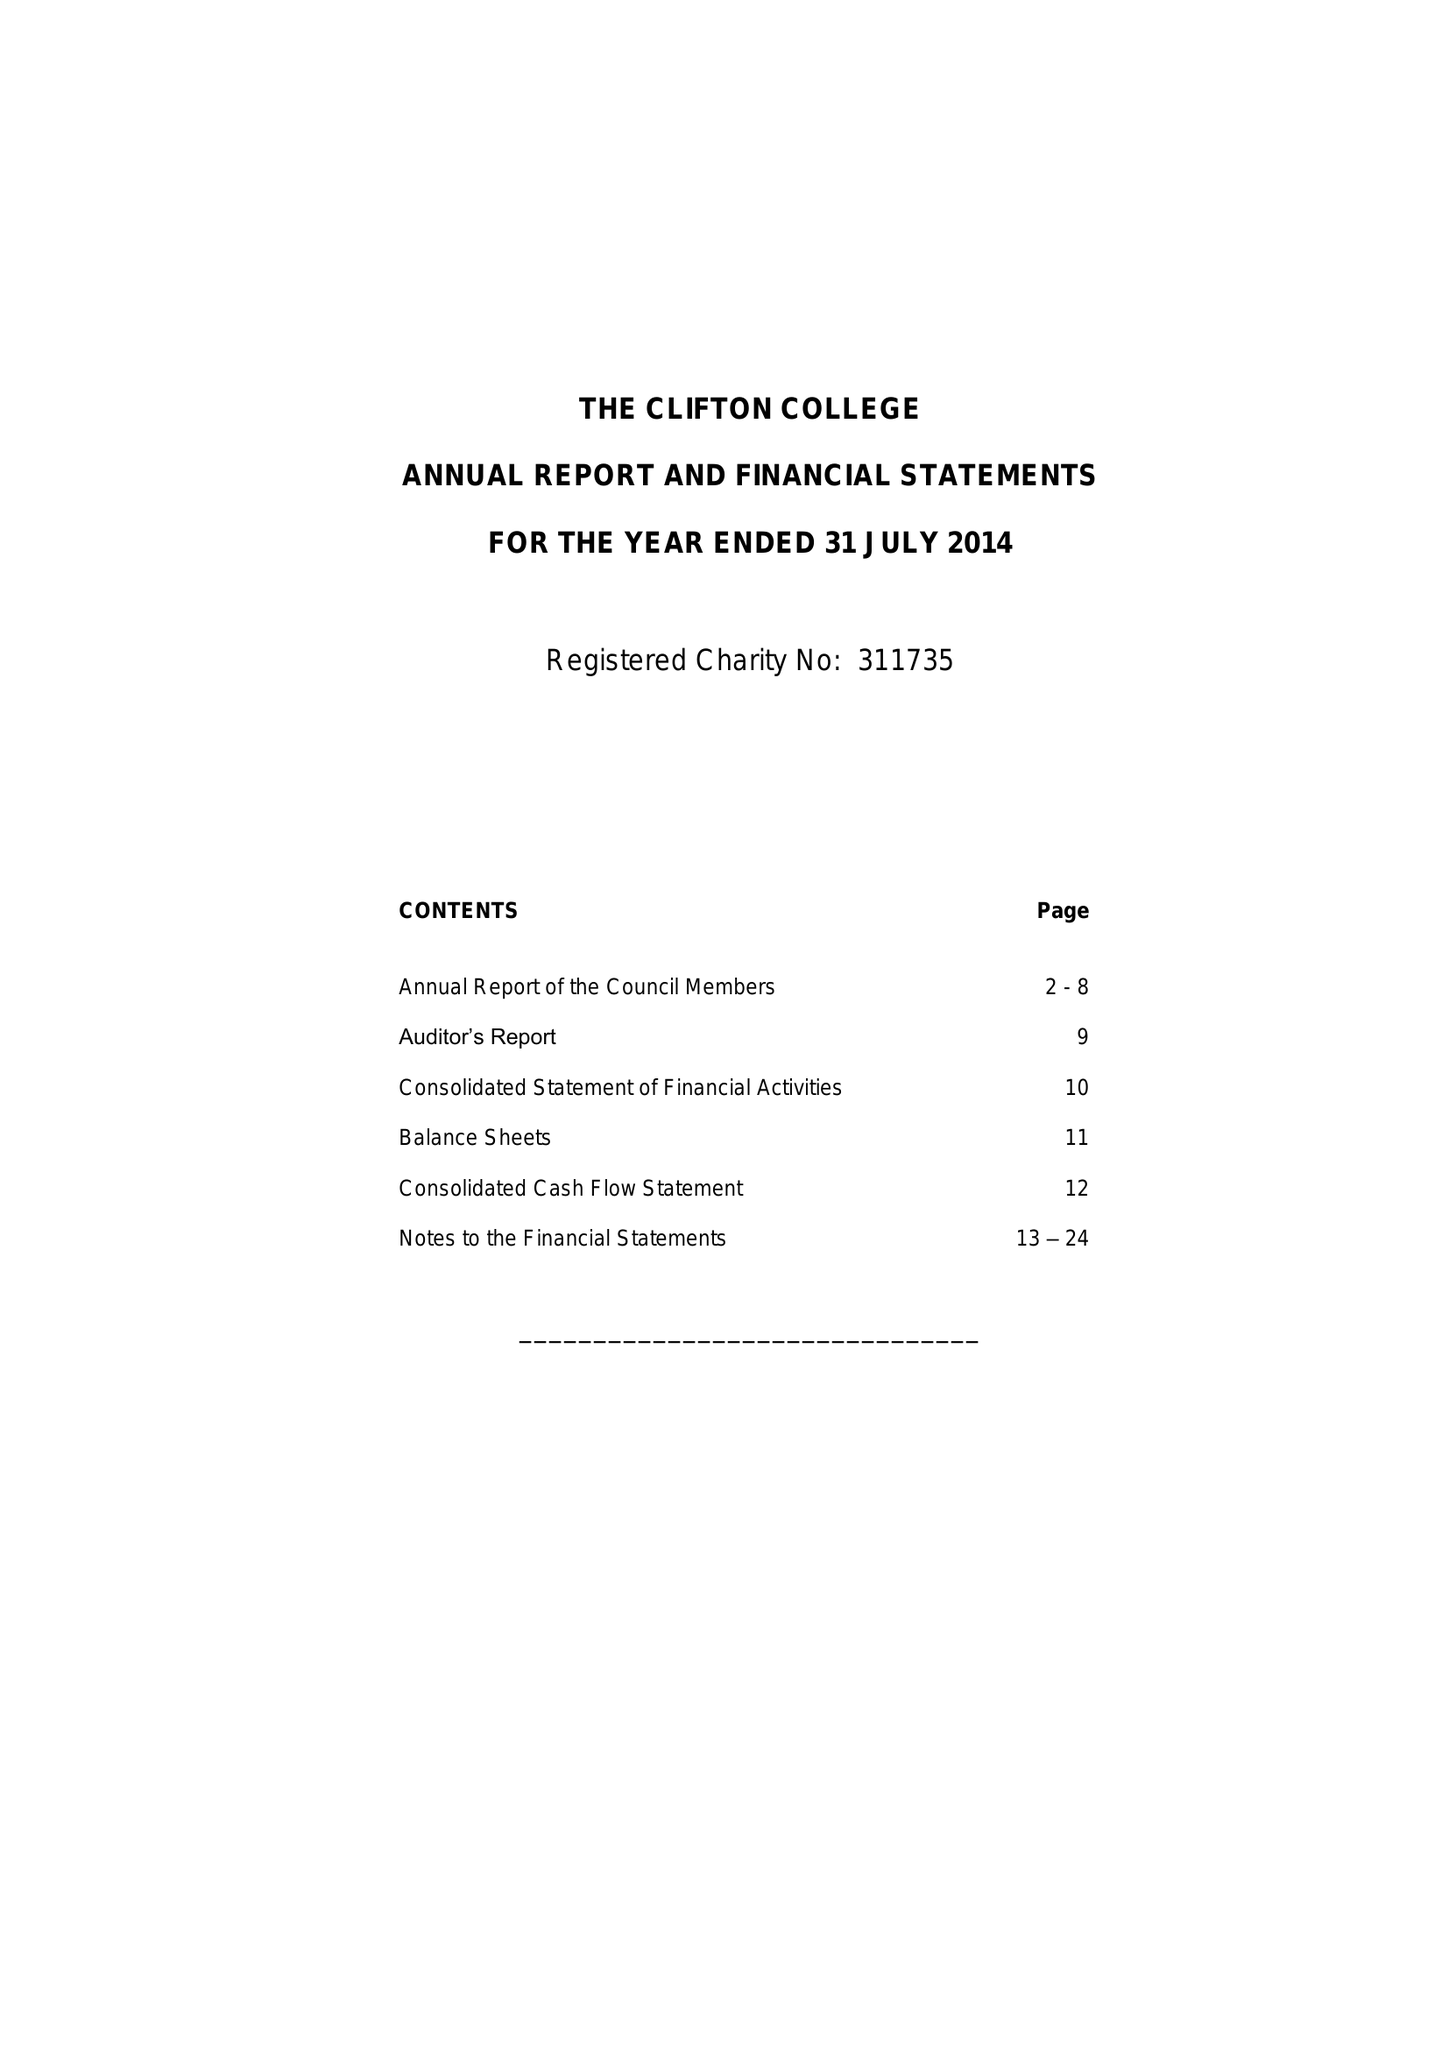What is the value for the address__postcode?
Answer the question using a single word or phrase. BS8 3JH 